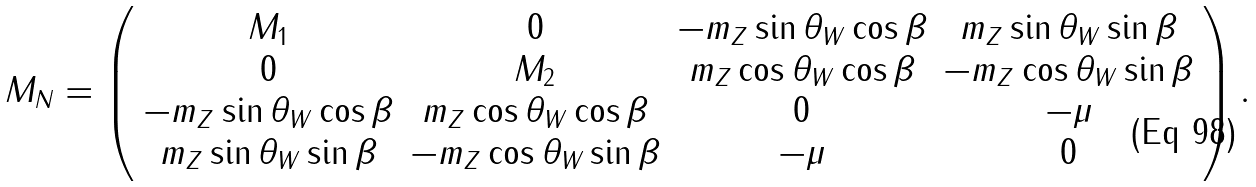<formula> <loc_0><loc_0><loc_500><loc_500>M _ { N } = \left ( \begin{array} { c c c c } { { M _ { 1 } } } & { 0 } & { { - m _ { Z } \sin \theta _ { W } \cos \beta } } & { { m _ { Z } \sin \theta _ { W } \sin \beta } } \\ { 0 } & { { M _ { 2 } } } & { { m _ { Z } \cos \theta _ { W } \cos \beta } } & { { - m _ { Z } \cos \theta _ { W } \sin \beta } } \\ { { - m _ { Z } \sin \theta _ { W } \cos \beta } } & { { m _ { Z } \cos \theta _ { W } \cos \beta } } & { 0 } & { - \mu } \\ { { m _ { Z } \sin \theta _ { W } \sin \beta } } & { { - m _ { Z } \cos \theta _ { W } \sin \beta } } & { - \mu } & { 0 } \end{array} \right ) .</formula> 